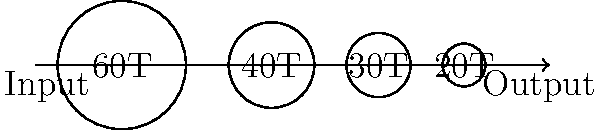A multi-stage gearbox consists of four gears arranged as shown in the diagram. The input gear has 60 teeth, followed by gears with 40, 30, and 20 teeth respectively. If the input shaft rotates at 1200 RPM, what is the output shaft speed in RPM? To solve this problem, we need to calculate the overall gear ratio and then use it to determine the output shaft speed. Let's break it down step-by-step:

1. Calculate the gear ratio for each stage:
   Stage 1: $r_1 = \frac{40}{60} = \frac{2}{3}$
   Stage 2: $r_2 = \frac{30}{40} = \frac{3}{4}$
   Stage 3: $r_3 = \frac{20}{30} = \frac{2}{3}$

2. Calculate the overall gear ratio by multiplying the individual ratios:
   $r_{total} = r_1 \times r_2 \times r_3 = \frac{2}{3} \times \frac{3}{4} \times \frac{2}{3} = \frac{1}{3}$

3. Use the gear ratio formula to calculate the output speed:
   $\frac{\text{Output Speed}}{\text{Input Speed}} = \frac{1}{\text{Gear Ratio}}$

4. Substitute the known values:
   $\frac{\text{Output Speed}}{1200 \text{ RPM}} = \frac{1}{\frac{1}{3}} = 3$

5. Solve for the output speed:
   $\text{Output Speed} = 1200 \text{ RPM} \times 3 = 3600 \text{ RPM}$

Therefore, the output shaft speed is 3600 RPM.
Answer: 3600 RPM 